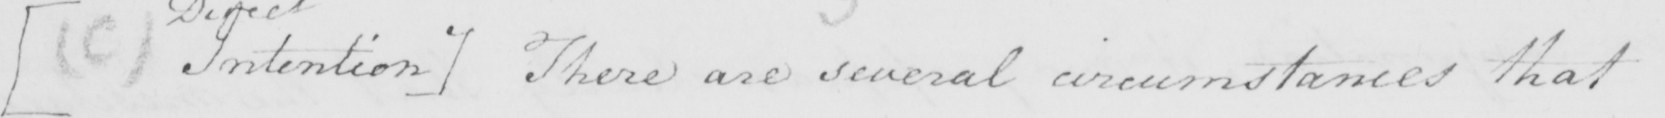What text is written in this handwritten line? [  ( C )  Intention ]  There are several circumstances that 